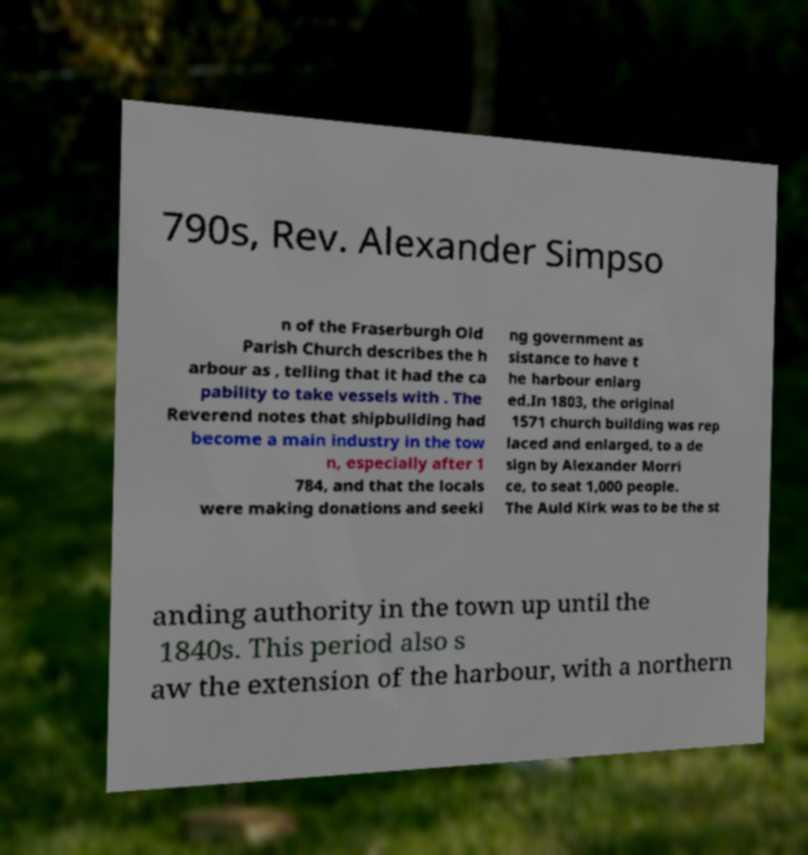Please read and relay the text visible in this image. What does it say? 790s, Rev. Alexander Simpso n of the Fraserburgh Old Parish Church describes the h arbour as , telling that it had the ca pability to take vessels with . The Reverend notes that shipbuilding had become a main industry in the tow n, especially after 1 784, and that the locals were making donations and seeki ng government as sistance to have t he harbour enlarg ed.In 1803, the original 1571 church building was rep laced and enlarged, to a de sign by Alexander Morri ce, to seat 1,000 people. The Auld Kirk was to be the st anding authority in the town up until the 1840s. This period also s aw the extension of the harbour, with a northern 